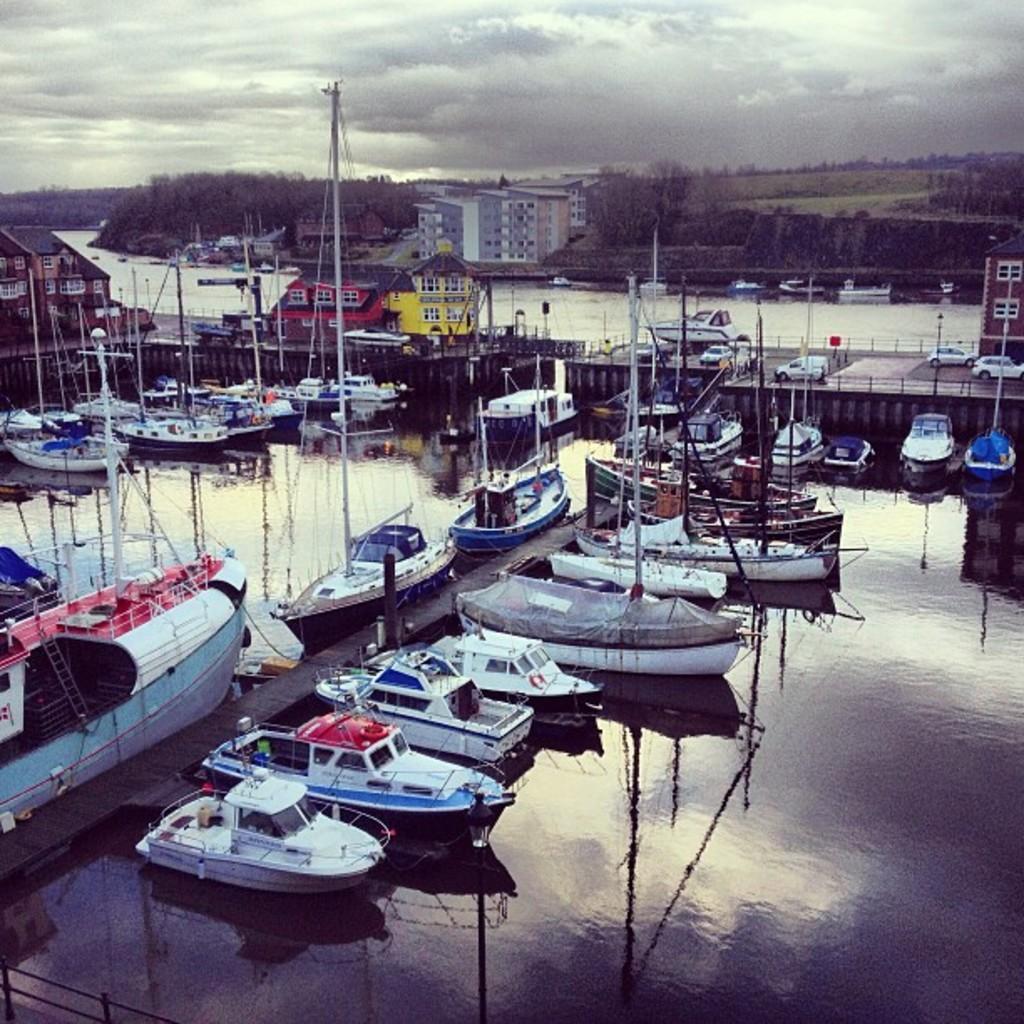Can you describe this image briefly? In this picture I can see boats on the water. In the background I can see buildings, vehicles and trees. I can also see the sky. 